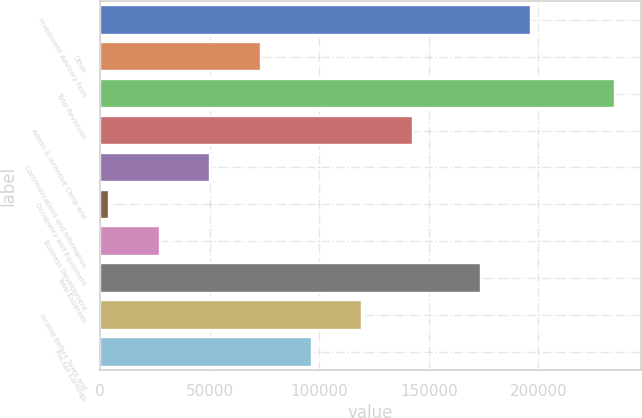Convert chart to OTSL. <chart><loc_0><loc_0><loc_500><loc_500><bar_chart><fcel>Investment Advisory Fees<fcel>Other<fcel>Total Revenues<fcel>Admin & Incentive Comp and<fcel>Communications and Information<fcel>Occupancy and Equipment<fcel>Business Development<fcel>Total Expenses<fcel>Income Before Taxes and<fcel>Pre-tax Earnings<nl><fcel>196790<fcel>73469.7<fcel>234875<fcel>142643<fcel>50411.8<fcel>4296<fcel>27353.9<fcel>173732<fcel>119586<fcel>96527.6<nl></chart> 